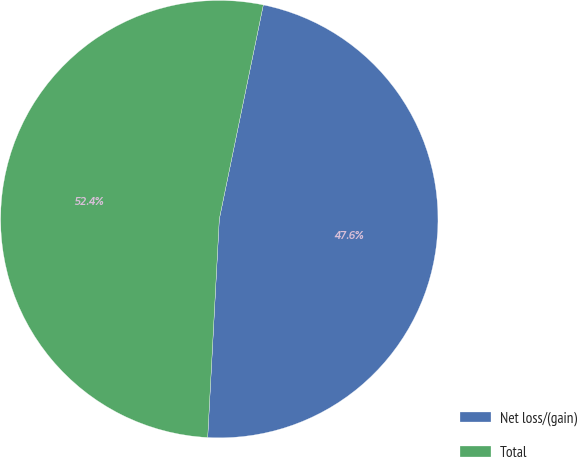Convert chart. <chart><loc_0><loc_0><loc_500><loc_500><pie_chart><fcel>Net loss/(gain)<fcel>Total<nl><fcel>47.62%<fcel>52.38%<nl></chart> 